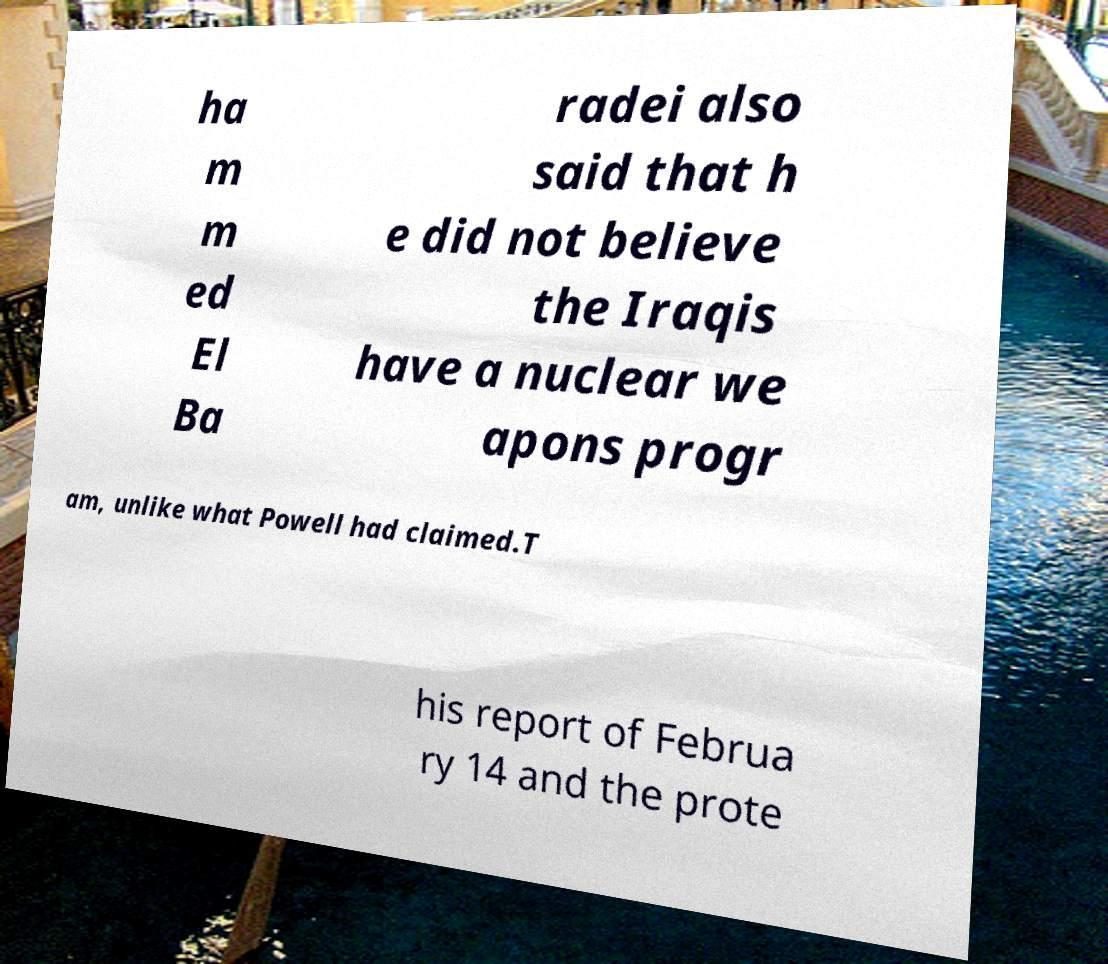I need the written content from this picture converted into text. Can you do that? ha m m ed El Ba radei also said that h e did not believe the Iraqis have a nuclear we apons progr am, unlike what Powell had claimed.T his report of Februa ry 14 and the prote 